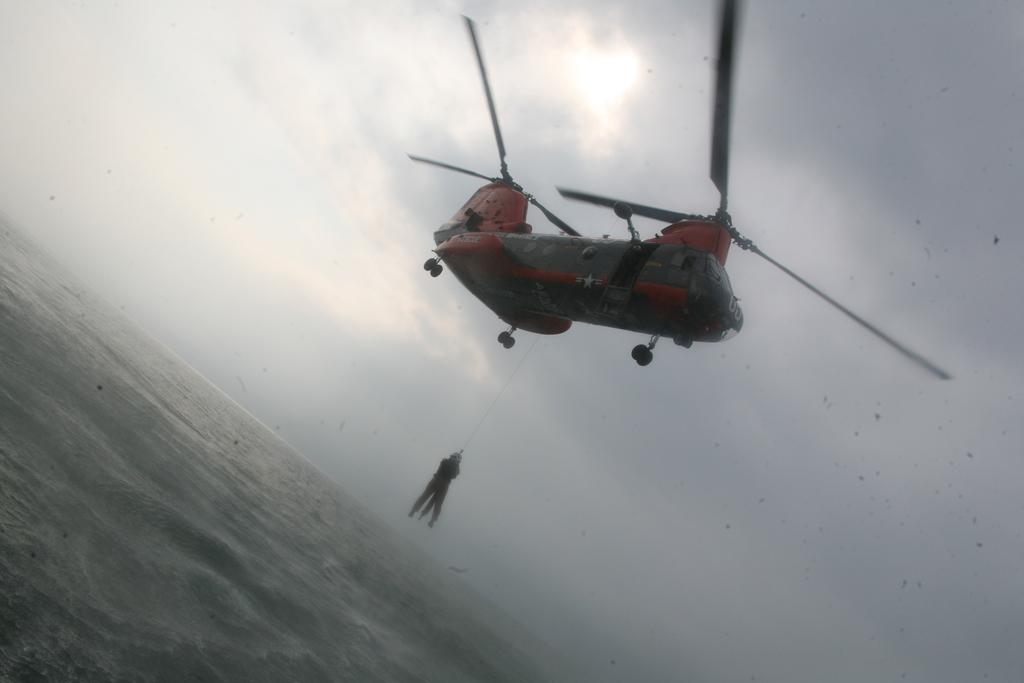What can be seen at the top of the image? The sky is visible towards the top of the image. What is the main subject in the image? There is an aircraft in the image. What is the man doing in the image? The man is hanging in the image. What is the man holding in the image? The man is holding an object. What can be seen at the bottom of the image? There is water visible towards the bottom of the image. What type of apple is being distributed by the man in the image? There is no apple present in the image, nor is there any indication of distribution. 